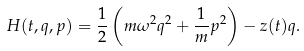Convert formula to latex. <formula><loc_0><loc_0><loc_500><loc_500>H ( t , q , p ) = \frac { 1 } { 2 } \left ( m \omega ^ { 2 } q ^ { 2 } + \frac { 1 } { m } p ^ { 2 } \right ) - z ( t ) q .</formula> 